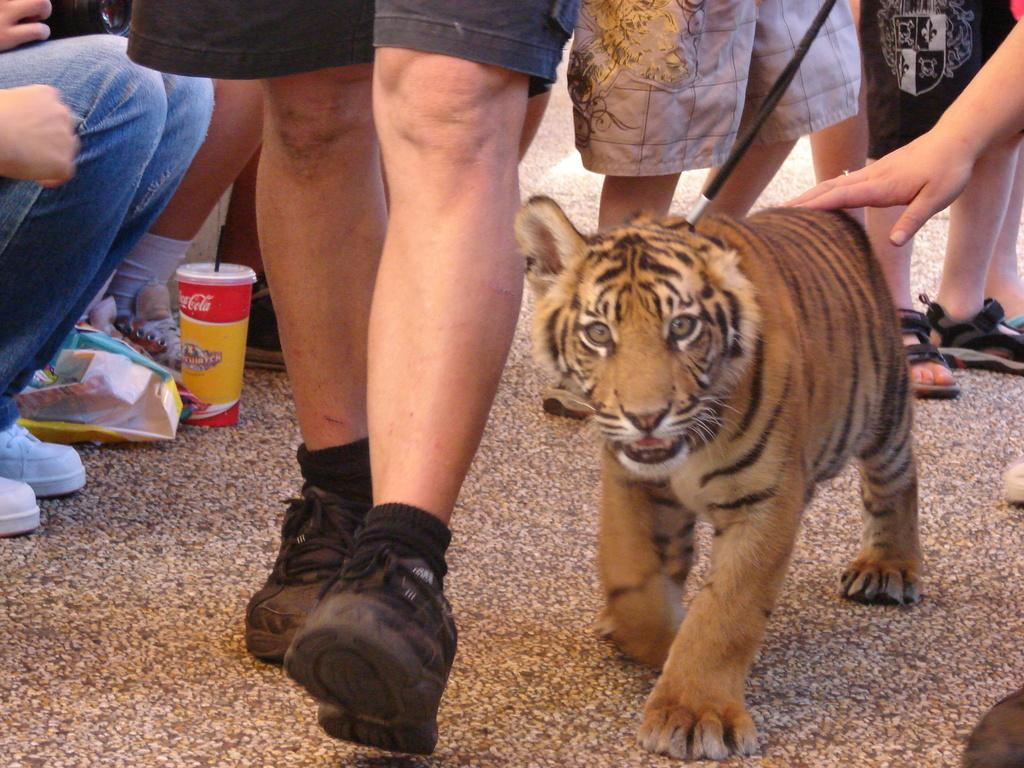What body parts can be seen in the image? Legs and hands are visible in the image. What object is present in the image? There is a glass in the image. What animal is featured in the image? There is a tiger in the image. What type of footwear are most people wearing in the image? Most of the people in the image are wearing shoes. How many eggs are being held by the tiger in the image? There are no eggs present in the image, and the tiger is not holding any. What type of insect can be seen crawling on the glass in the image? There is no insect visible on the glass in the image. 